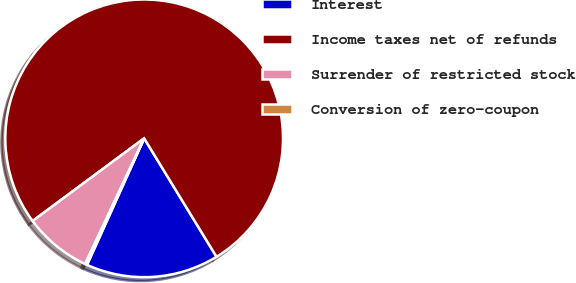<chart> <loc_0><loc_0><loc_500><loc_500><pie_chart><fcel>Interest<fcel>Income taxes net of refunds<fcel>Surrender of restricted stock<fcel>Conversion of zero-coupon<nl><fcel>15.48%<fcel>76.43%<fcel>7.86%<fcel>0.24%<nl></chart> 